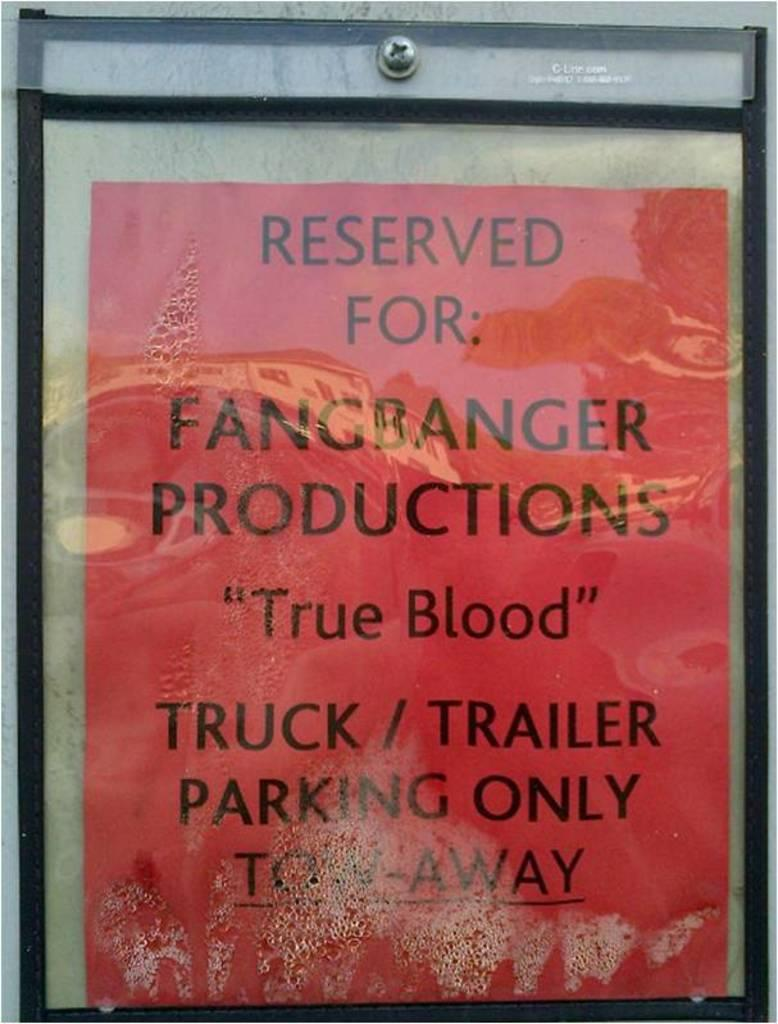Provide a one-sentence caption for the provided image. A red sign reserving parking for Fangbabger Productions threatens unauthorized vehicles may be towed. 